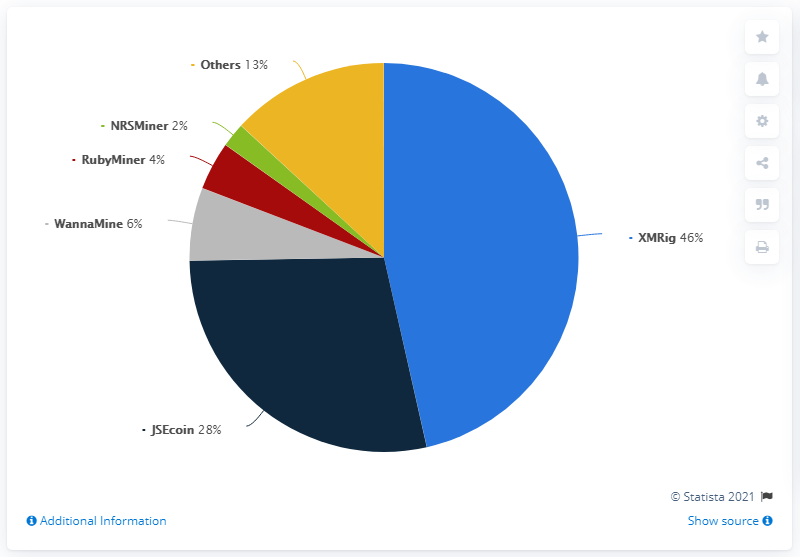Draw attention to some important aspects in this diagram. The color of WannaMine in a pie segment is gray. The sum total of JSECoin and RubyMiner is not greater than XMRig. According to a recent report, XMRig was the most commonly detected cryptomining malware worldwide in 2020. 